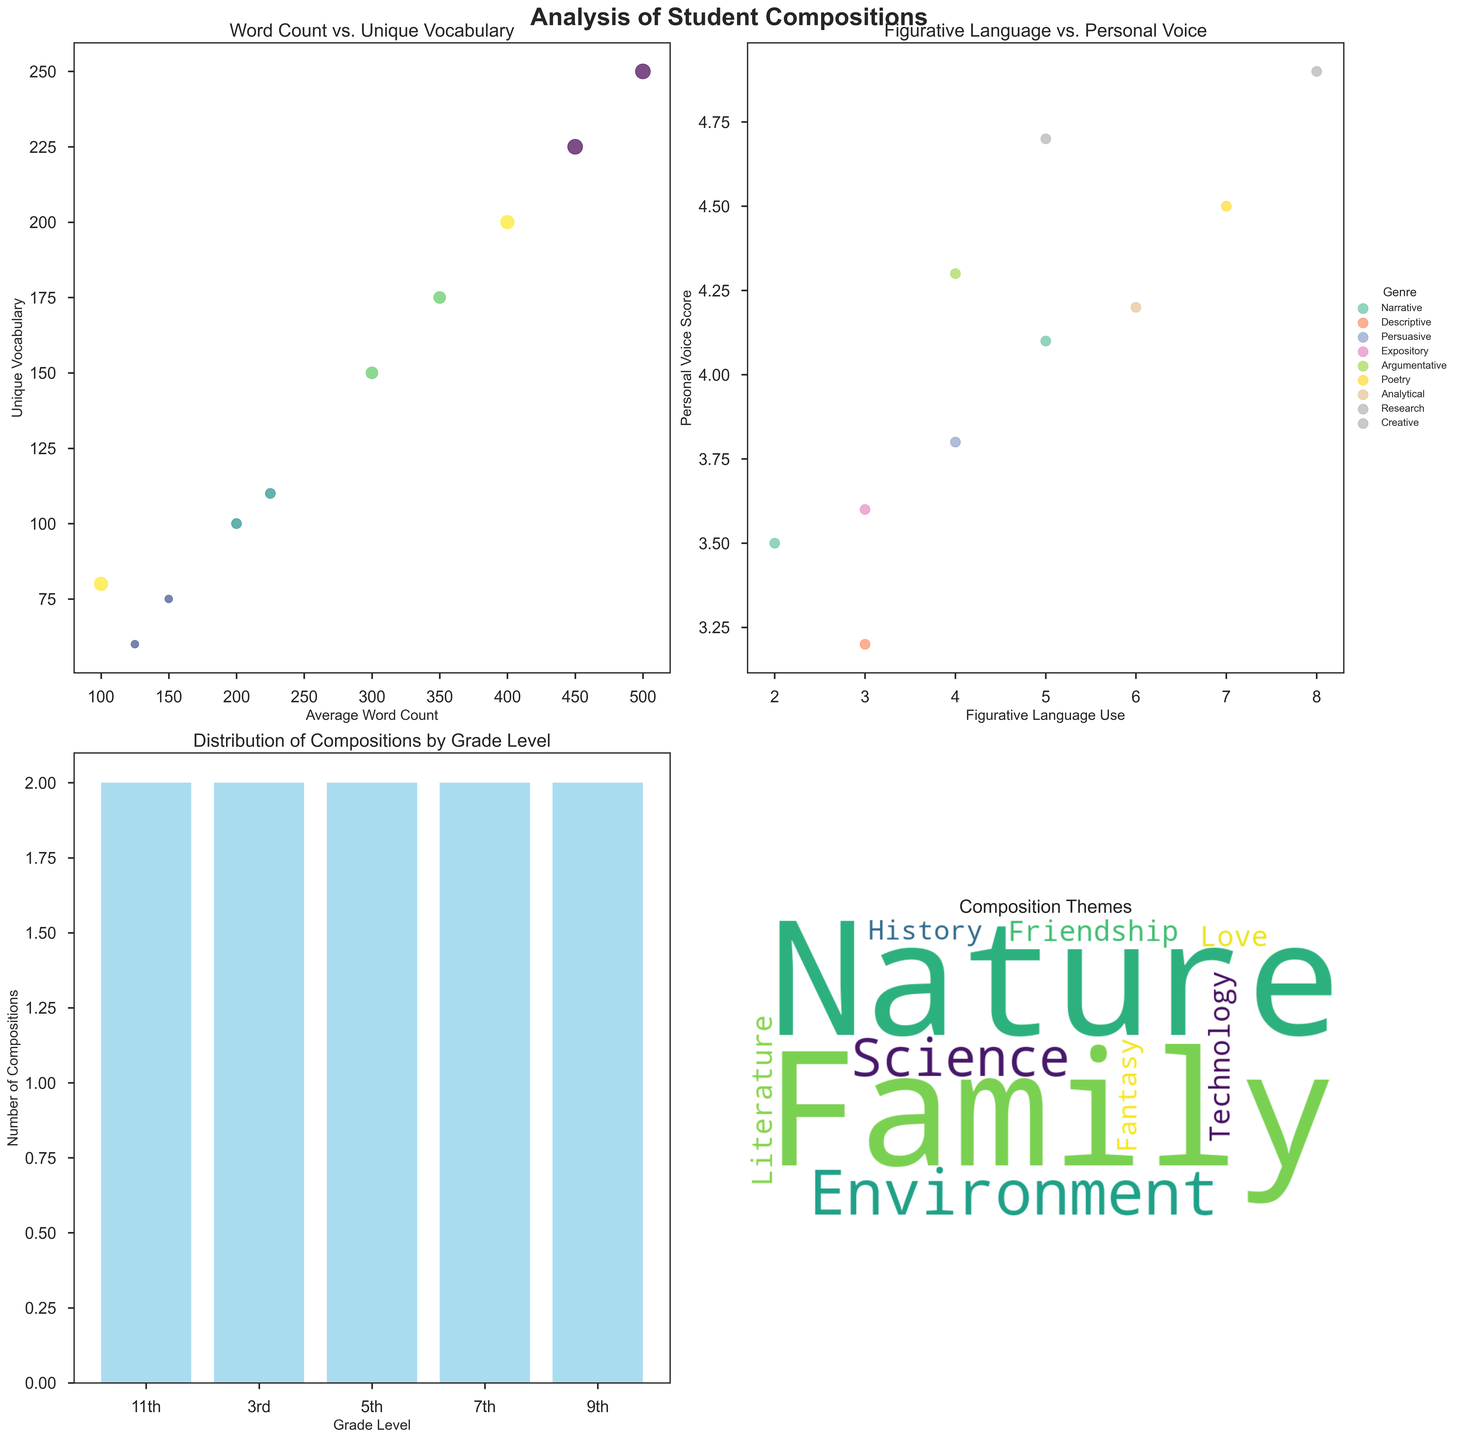What is the title of the first subplot? The title of the first subplot is located above the scatter plot in the top-left corner and reads "Word Count vs. Unique Vocabulary".
Answer: Word Count vs. Unique Vocabulary How many themes are included in the word cloud? By examining the distinct words in the word cloud, one can identify that there are 10 separate themes visualized within the word cloud.
Answer: 10 Which grade level has the highest occurrence of compositions? The bar plot in the bottom-left corner shows the distribution of compositions by grade level. The tallest bar, representing the highest frequency, belongs to the 11th grade.
Answer: 11th grade In general, how does the use of figurative language relate to personal voice scores? In the scatter plot on the top-right showing "Figurative Language vs. Personal Voice," compositions with higher figurative language use tend to cluster towards higher personal voice scores. This indicates a positive correlation between the two metrics.
Answer: Positive correlation Which genre uses the highest amount of figurative language? By inspecting the scatter plot on the top-right, we see that the genre "Poetry" (indicated by the specific marker for genres and layout) corresponds to the highest value of figurative language use, around 7.
Answer: Poetry Compare the average word count for 7th-grade argumentative compositions to the 9th-grade analytical compositions. The scatter plot for "Word Count vs. Unique Vocabulary" shows the points for different compositions. For 7th-grade argumentative, it's 350 words, while for 9th-grade analytical, it's 400 words. Thus, the 9th-grade compositions have a higher average word count.
Answer: 9th grade higher What is the theme of the composition with the most words? By finding the point with the highest x-coordinate (i.e., highest average word count) in the scatter plot on the top-left, it corresponds to the 11th-grade research composition theme "History" at 500 words.
Answer: History Which subplot shows a categorical distribution? The subplot in the bottom-left corner is a bar plot that shows the categorical distribution of compositions by grade level.
Answer: Bottom-left subplot What genre has the second-highest personal voice score? From the scatter plot on the top-right, after identifying the highest score, which is "Creative" at 4.9, the second-highest score (4.7) corresponds to the genre "Research".
Answer: Research 